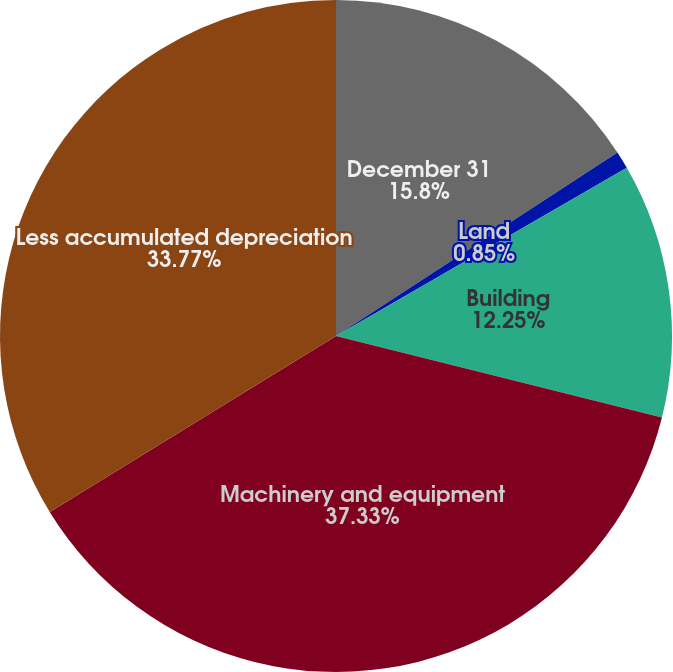<chart> <loc_0><loc_0><loc_500><loc_500><pie_chart><fcel>December 31<fcel>Land<fcel>Building<fcel>Machinery and equipment<fcel>Less accumulated depreciation<nl><fcel>15.8%<fcel>0.85%<fcel>12.25%<fcel>37.33%<fcel>33.77%<nl></chart> 